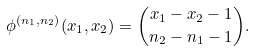Convert formula to latex. <formula><loc_0><loc_0><loc_500><loc_500>\phi ^ { ( n _ { 1 } , n _ { 2 } ) } ( x _ { 1 } , x _ { 2 } ) = \binom { x _ { 1 } - x _ { 2 } - 1 } { n _ { 2 } - n _ { 1 } - 1 } .</formula> 